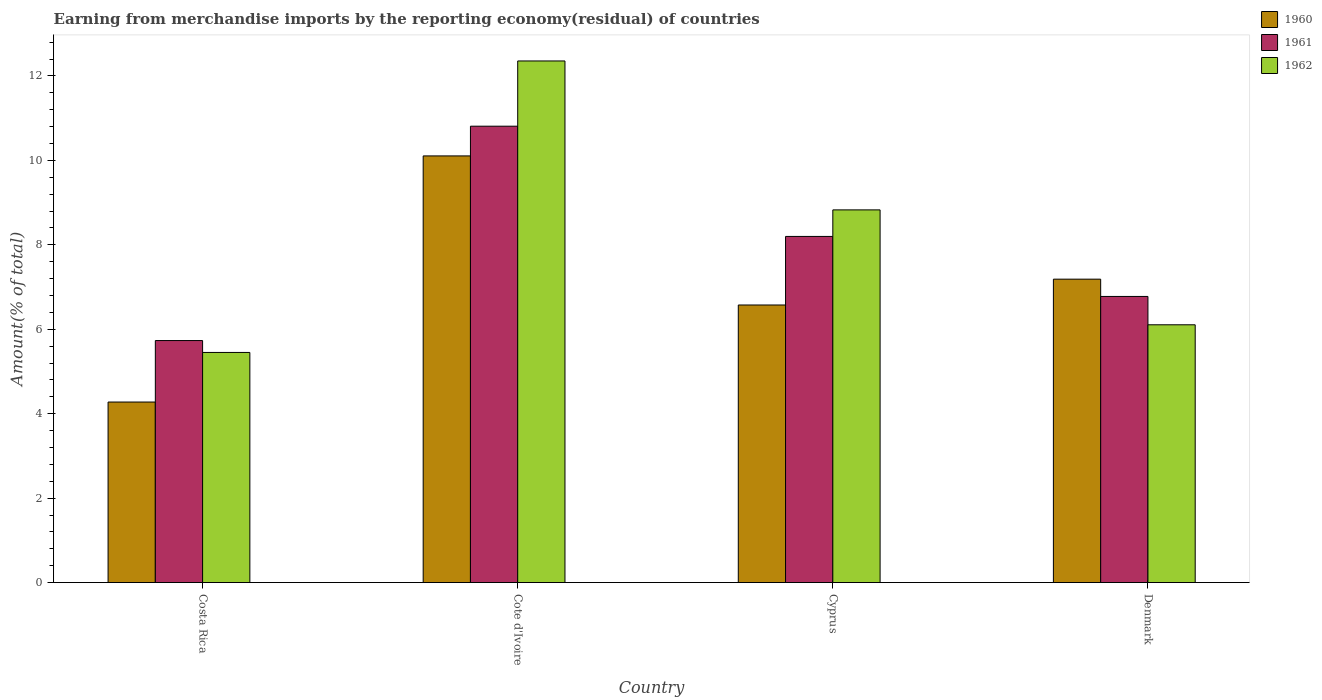How many different coloured bars are there?
Your response must be concise. 3. How many groups of bars are there?
Make the answer very short. 4. Are the number of bars per tick equal to the number of legend labels?
Your response must be concise. Yes. Are the number of bars on each tick of the X-axis equal?
Your answer should be compact. Yes. How many bars are there on the 4th tick from the right?
Provide a short and direct response. 3. What is the label of the 3rd group of bars from the left?
Keep it short and to the point. Cyprus. What is the percentage of amount earned from merchandise imports in 1961 in Costa Rica?
Offer a terse response. 5.73. Across all countries, what is the maximum percentage of amount earned from merchandise imports in 1962?
Your answer should be compact. 12.36. Across all countries, what is the minimum percentage of amount earned from merchandise imports in 1962?
Keep it short and to the point. 5.45. In which country was the percentage of amount earned from merchandise imports in 1960 maximum?
Your response must be concise. Cote d'Ivoire. What is the total percentage of amount earned from merchandise imports in 1961 in the graph?
Ensure brevity in your answer.  31.52. What is the difference between the percentage of amount earned from merchandise imports in 1962 in Costa Rica and that in Cote d'Ivoire?
Your response must be concise. -6.9. What is the difference between the percentage of amount earned from merchandise imports in 1961 in Cyprus and the percentage of amount earned from merchandise imports in 1962 in Cote d'Ivoire?
Your response must be concise. -4.16. What is the average percentage of amount earned from merchandise imports in 1960 per country?
Provide a succinct answer. 7.04. What is the difference between the percentage of amount earned from merchandise imports of/in 1960 and percentage of amount earned from merchandise imports of/in 1962 in Denmark?
Your response must be concise. 1.08. What is the ratio of the percentage of amount earned from merchandise imports in 1960 in Cyprus to that in Denmark?
Ensure brevity in your answer.  0.91. Is the difference between the percentage of amount earned from merchandise imports in 1960 in Costa Rica and Cote d'Ivoire greater than the difference between the percentage of amount earned from merchandise imports in 1962 in Costa Rica and Cote d'Ivoire?
Your response must be concise. Yes. What is the difference between the highest and the second highest percentage of amount earned from merchandise imports in 1962?
Make the answer very short. -3.53. What is the difference between the highest and the lowest percentage of amount earned from merchandise imports in 1961?
Your answer should be very brief. 5.08. In how many countries, is the percentage of amount earned from merchandise imports in 1961 greater than the average percentage of amount earned from merchandise imports in 1961 taken over all countries?
Give a very brief answer. 2. Is the sum of the percentage of amount earned from merchandise imports in 1961 in Cote d'Ivoire and Cyprus greater than the maximum percentage of amount earned from merchandise imports in 1960 across all countries?
Make the answer very short. Yes. What does the 2nd bar from the left in Cyprus represents?
Keep it short and to the point. 1961. Is it the case that in every country, the sum of the percentage of amount earned from merchandise imports in 1960 and percentage of amount earned from merchandise imports in 1962 is greater than the percentage of amount earned from merchandise imports in 1961?
Your answer should be compact. Yes. How many bars are there?
Your answer should be very brief. 12. What is the difference between two consecutive major ticks on the Y-axis?
Keep it short and to the point. 2. Are the values on the major ticks of Y-axis written in scientific E-notation?
Provide a succinct answer. No. What is the title of the graph?
Give a very brief answer. Earning from merchandise imports by the reporting economy(residual) of countries. What is the label or title of the X-axis?
Your response must be concise. Country. What is the label or title of the Y-axis?
Provide a short and direct response. Amount(% of total). What is the Amount(% of total) of 1960 in Costa Rica?
Ensure brevity in your answer.  4.28. What is the Amount(% of total) of 1961 in Costa Rica?
Ensure brevity in your answer.  5.73. What is the Amount(% of total) of 1962 in Costa Rica?
Ensure brevity in your answer.  5.45. What is the Amount(% of total) in 1960 in Cote d'Ivoire?
Ensure brevity in your answer.  10.11. What is the Amount(% of total) of 1961 in Cote d'Ivoire?
Ensure brevity in your answer.  10.81. What is the Amount(% of total) of 1962 in Cote d'Ivoire?
Give a very brief answer. 12.36. What is the Amount(% of total) of 1960 in Cyprus?
Make the answer very short. 6.58. What is the Amount(% of total) in 1961 in Cyprus?
Offer a very short reply. 8.2. What is the Amount(% of total) of 1962 in Cyprus?
Offer a very short reply. 8.83. What is the Amount(% of total) in 1960 in Denmark?
Give a very brief answer. 7.19. What is the Amount(% of total) of 1961 in Denmark?
Provide a succinct answer. 6.78. What is the Amount(% of total) in 1962 in Denmark?
Offer a terse response. 6.11. Across all countries, what is the maximum Amount(% of total) in 1960?
Make the answer very short. 10.11. Across all countries, what is the maximum Amount(% of total) in 1961?
Your answer should be very brief. 10.81. Across all countries, what is the maximum Amount(% of total) of 1962?
Offer a terse response. 12.36. Across all countries, what is the minimum Amount(% of total) in 1960?
Offer a terse response. 4.28. Across all countries, what is the minimum Amount(% of total) of 1961?
Give a very brief answer. 5.73. Across all countries, what is the minimum Amount(% of total) of 1962?
Offer a very short reply. 5.45. What is the total Amount(% of total) in 1960 in the graph?
Offer a very short reply. 28.15. What is the total Amount(% of total) in 1961 in the graph?
Offer a terse response. 31.52. What is the total Amount(% of total) of 1962 in the graph?
Provide a short and direct response. 32.74. What is the difference between the Amount(% of total) of 1960 in Costa Rica and that in Cote d'Ivoire?
Your answer should be very brief. -5.83. What is the difference between the Amount(% of total) of 1961 in Costa Rica and that in Cote d'Ivoire?
Your response must be concise. -5.08. What is the difference between the Amount(% of total) of 1962 in Costa Rica and that in Cote d'Ivoire?
Make the answer very short. -6.9. What is the difference between the Amount(% of total) of 1960 in Costa Rica and that in Cyprus?
Offer a terse response. -2.3. What is the difference between the Amount(% of total) in 1961 in Costa Rica and that in Cyprus?
Your answer should be compact. -2.47. What is the difference between the Amount(% of total) of 1962 in Costa Rica and that in Cyprus?
Provide a short and direct response. -3.38. What is the difference between the Amount(% of total) of 1960 in Costa Rica and that in Denmark?
Provide a succinct answer. -2.91. What is the difference between the Amount(% of total) of 1961 in Costa Rica and that in Denmark?
Keep it short and to the point. -1.04. What is the difference between the Amount(% of total) of 1962 in Costa Rica and that in Denmark?
Provide a short and direct response. -0.66. What is the difference between the Amount(% of total) of 1960 in Cote d'Ivoire and that in Cyprus?
Keep it short and to the point. 3.53. What is the difference between the Amount(% of total) in 1961 in Cote d'Ivoire and that in Cyprus?
Your answer should be very brief. 2.61. What is the difference between the Amount(% of total) of 1962 in Cote d'Ivoire and that in Cyprus?
Offer a very short reply. 3.53. What is the difference between the Amount(% of total) in 1960 in Cote d'Ivoire and that in Denmark?
Give a very brief answer. 2.92. What is the difference between the Amount(% of total) in 1961 in Cote d'Ivoire and that in Denmark?
Keep it short and to the point. 4.03. What is the difference between the Amount(% of total) of 1962 in Cote d'Ivoire and that in Denmark?
Give a very brief answer. 6.25. What is the difference between the Amount(% of total) of 1960 in Cyprus and that in Denmark?
Your answer should be compact. -0.61. What is the difference between the Amount(% of total) of 1961 in Cyprus and that in Denmark?
Offer a very short reply. 1.42. What is the difference between the Amount(% of total) in 1962 in Cyprus and that in Denmark?
Your response must be concise. 2.72. What is the difference between the Amount(% of total) in 1960 in Costa Rica and the Amount(% of total) in 1961 in Cote d'Ivoire?
Your answer should be very brief. -6.53. What is the difference between the Amount(% of total) of 1960 in Costa Rica and the Amount(% of total) of 1962 in Cote d'Ivoire?
Offer a terse response. -8.08. What is the difference between the Amount(% of total) of 1961 in Costa Rica and the Amount(% of total) of 1962 in Cote d'Ivoire?
Offer a terse response. -6.62. What is the difference between the Amount(% of total) of 1960 in Costa Rica and the Amount(% of total) of 1961 in Cyprus?
Your answer should be very brief. -3.92. What is the difference between the Amount(% of total) of 1960 in Costa Rica and the Amount(% of total) of 1962 in Cyprus?
Keep it short and to the point. -4.55. What is the difference between the Amount(% of total) of 1961 in Costa Rica and the Amount(% of total) of 1962 in Cyprus?
Your answer should be very brief. -3.1. What is the difference between the Amount(% of total) in 1960 in Costa Rica and the Amount(% of total) in 1961 in Denmark?
Offer a very short reply. -2.5. What is the difference between the Amount(% of total) of 1960 in Costa Rica and the Amount(% of total) of 1962 in Denmark?
Provide a short and direct response. -1.83. What is the difference between the Amount(% of total) in 1961 in Costa Rica and the Amount(% of total) in 1962 in Denmark?
Your response must be concise. -0.37. What is the difference between the Amount(% of total) in 1960 in Cote d'Ivoire and the Amount(% of total) in 1961 in Cyprus?
Your response must be concise. 1.91. What is the difference between the Amount(% of total) of 1960 in Cote d'Ivoire and the Amount(% of total) of 1962 in Cyprus?
Give a very brief answer. 1.28. What is the difference between the Amount(% of total) of 1961 in Cote d'Ivoire and the Amount(% of total) of 1962 in Cyprus?
Offer a terse response. 1.98. What is the difference between the Amount(% of total) of 1960 in Cote d'Ivoire and the Amount(% of total) of 1961 in Denmark?
Provide a short and direct response. 3.33. What is the difference between the Amount(% of total) in 1960 in Cote d'Ivoire and the Amount(% of total) in 1962 in Denmark?
Keep it short and to the point. 4. What is the difference between the Amount(% of total) in 1961 in Cote d'Ivoire and the Amount(% of total) in 1962 in Denmark?
Provide a short and direct response. 4.7. What is the difference between the Amount(% of total) in 1960 in Cyprus and the Amount(% of total) in 1961 in Denmark?
Ensure brevity in your answer.  -0.2. What is the difference between the Amount(% of total) of 1960 in Cyprus and the Amount(% of total) of 1962 in Denmark?
Your answer should be compact. 0.47. What is the difference between the Amount(% of total) in 1961 in Cyprus and the Amount(% of total) in 1962 in Denmark?
Make the answer very short. 2.09. What is the average Amount(% of total) in 1960 per country?
Your answer should be compact. 7.04. What is the average Amount(% of total) in 1961 per country?
Your answer should be very brief. 7.88. What is the average Amount(% of total) of 1962 per country?
Your response must be concise. 8.19. What is the difference between the Amount(% of total) in 1960 and Amount(% of total) in 1961 in Costa Rica?
Provide a short and direct response. -1.46. What is the difference between the Amount(% of total) in 1960 and Amount(% of total) in 1962 in Costa Rica?
Provide a short and direct response. -1.17. What is the difference between the Amount(% of total) of 1961 and Amount(% of total) of 1962 in Costa Rica?
Provide a short and direct response. 0.28. What is the difference between the Amount(% of total) in 1960 and Amount(% of total) in 1961 in Cote d'Ivoire?
Offer a very short reply. -0.7. What is the difference between the Amount(% of total) of 1960 and Amount(% of total) of 1962 in Cote d'Ivoire?
Offer a very short reply. -2.25. What is the difference between the Amount(% of total) of 1961 and Amount(% of total) of 1962 in Cote d'Ivoire?
Offer a very short reply. -1.55. What is the difference between the Amount(% of total) in 1960 and Amount(% of total) in 1961 in Cyprus?
Your answer should be very brief. -1.62. What is the difference between the Amount(% of total) in 1960 and Amount(% of total) in 1962 in Cyprus?
Provide a short and direct response. -2.25. What is the difference between the Amount(% of total) of 1961 and Amount(% of total) of 1962 in Cyprus?
Keep it short and to the point. -0.63. What is the difference between the Amount(% of total) in 1960 and Amount(% of total) in 1961 in Denmark?
Offer a very short reply. 0.41. What is the difference between the Amount(% of total) in 1960 and Amount(% of total) in 1962 in Denmark?
Provide a short and direct response. 1.08. What is the difference between the Amount(% of total) in 1961 and Amount(% of total) in 1962 in Denmark?
Keep it short and to the point. 0.67. What is the ratio of the Amount(% of total) of 1960 in Costa Rica to that in Cote d'Ivoire?
Ensure brevity in your answer.  0.42. What is the ratio of the Amount(% of total) of 1961 in Costa Rica to that in Cote d'Ivoire?
Make the answer very short. 0.53. What is the ratio of the Amount(% of total) of 1962 in Costa Rica to that in Cote d'Ivoire?
Ensure brevity in your answer.  0.44. What is the ratio of the Amount(% of total) of 1960 in Costa Rica to that in Cyprus?
Provide a succinct answer. 0.65. What is the ratio of the Amount(% of total) in 1961 in Costa Rica to that in Cyprus?
Your response must be concise. 0.7. What is the ratio of the Amount(% of total) in 1962 in Costa Rica to that in Cyprus?
Offer a terse response. 0.62. What is the ratio of the Amount(% of total) in 1960 in Costa Rica to that in Denmark?
Keep it short and to the point. 0.59. What is the ratio of the Amount(% of total) of 1961 in Costa Rica to that in Denmark?
Offer a very short reply. 0.85. What is the ratio of the Amount(% of total) of 1962 in Costa Rica to that in Denmark?
Offer a very short reply. 0.89. What is the ratio of the Amount(% of total) in 1960 in Cote d'Ivoire to that in Cyprus?
Ensure brevity in your answer.  1.54. What is the ratio of the Amount(% of total) in 1961 in Cote d'Ivoire to that in Cyprus?
Offer a very short reply. 1.32. What is the ratio of the Amount(% of total) of 1962 in Cote d'Ivoire to that in Cyprus?
Your answer should be very brief. 1.4. What is the ratio of the Amount(% of total) of 1960 in Cote d'Ivoire to that in Denmark?
Provide a succinct answer. 1.41. What is the ratio of the Amount(% of total) of 1961 in Cote d'Ivoire to that in Denmark?
Make the answer very short. 1.59. What is the ratio of the Amount(% of total) of 1962 in Cote d'Ivoire to that in Denmark?
Keep it short and to the point. 2.02. What is the ratio of the Amount(% of total) in 1960 in Cyprus to that in Denmark?
Your answer should be compact. 0.91. What is the ratio of the Amount(% of total) in 1961 in Cyprus to that in Denmark?
Your response must be concise. 1.21. What is the ratio of the Amount(% of total) of 1962 in Cyprus to that in Denmark?
Provide a short and direct response. 1.45. What is the difference between the highest and the second highest Amount(% of total) in 1960?
Provide a succinct answer. 2.92. What is the difference between the highest and the second highest Amount(% of total) of 1961?
Keep it short and to the point. 2.61. What is the difference between the highest and the second highest Amount(% of total) of 1962?
Provide a succinct answer. 3.53. What is the difference between the highest and the lowest Amount(% of total) in 1960?
Offer a terse response. 5.83. What is the difference between the highest and the lowest Amount(% of total) of 1961?
Your answer should be very brief. 5.08. What is the difference between the highest and the lowest Amount(% of total) of 1962?
Offer a terse response. 6.9. 